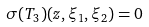<formula> <loc_0><loc_0><loc_500><loc_500>\sigma ( T _ { 3 } ) ( z , \xi _ { 1 } , \xi _ { 2 } ) = 0</formula> 